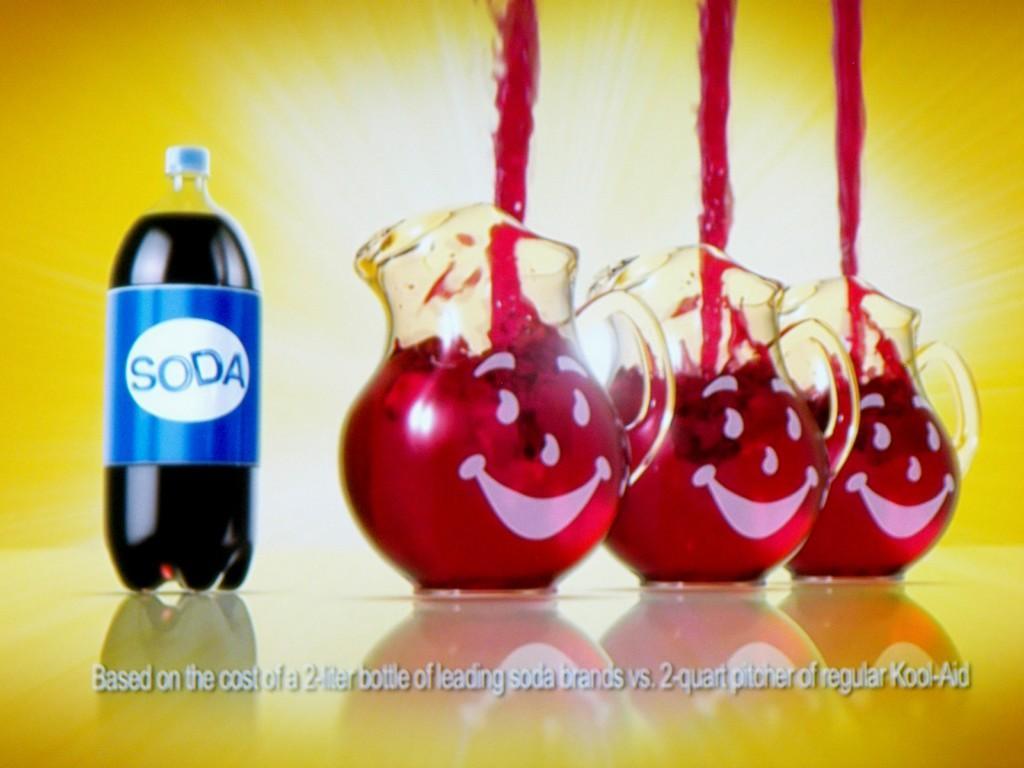Can you describe this image briefly? In this image we can see three jars on the right side of the image. On the left side of the image we can see a bottle with a label written SODA on it. 